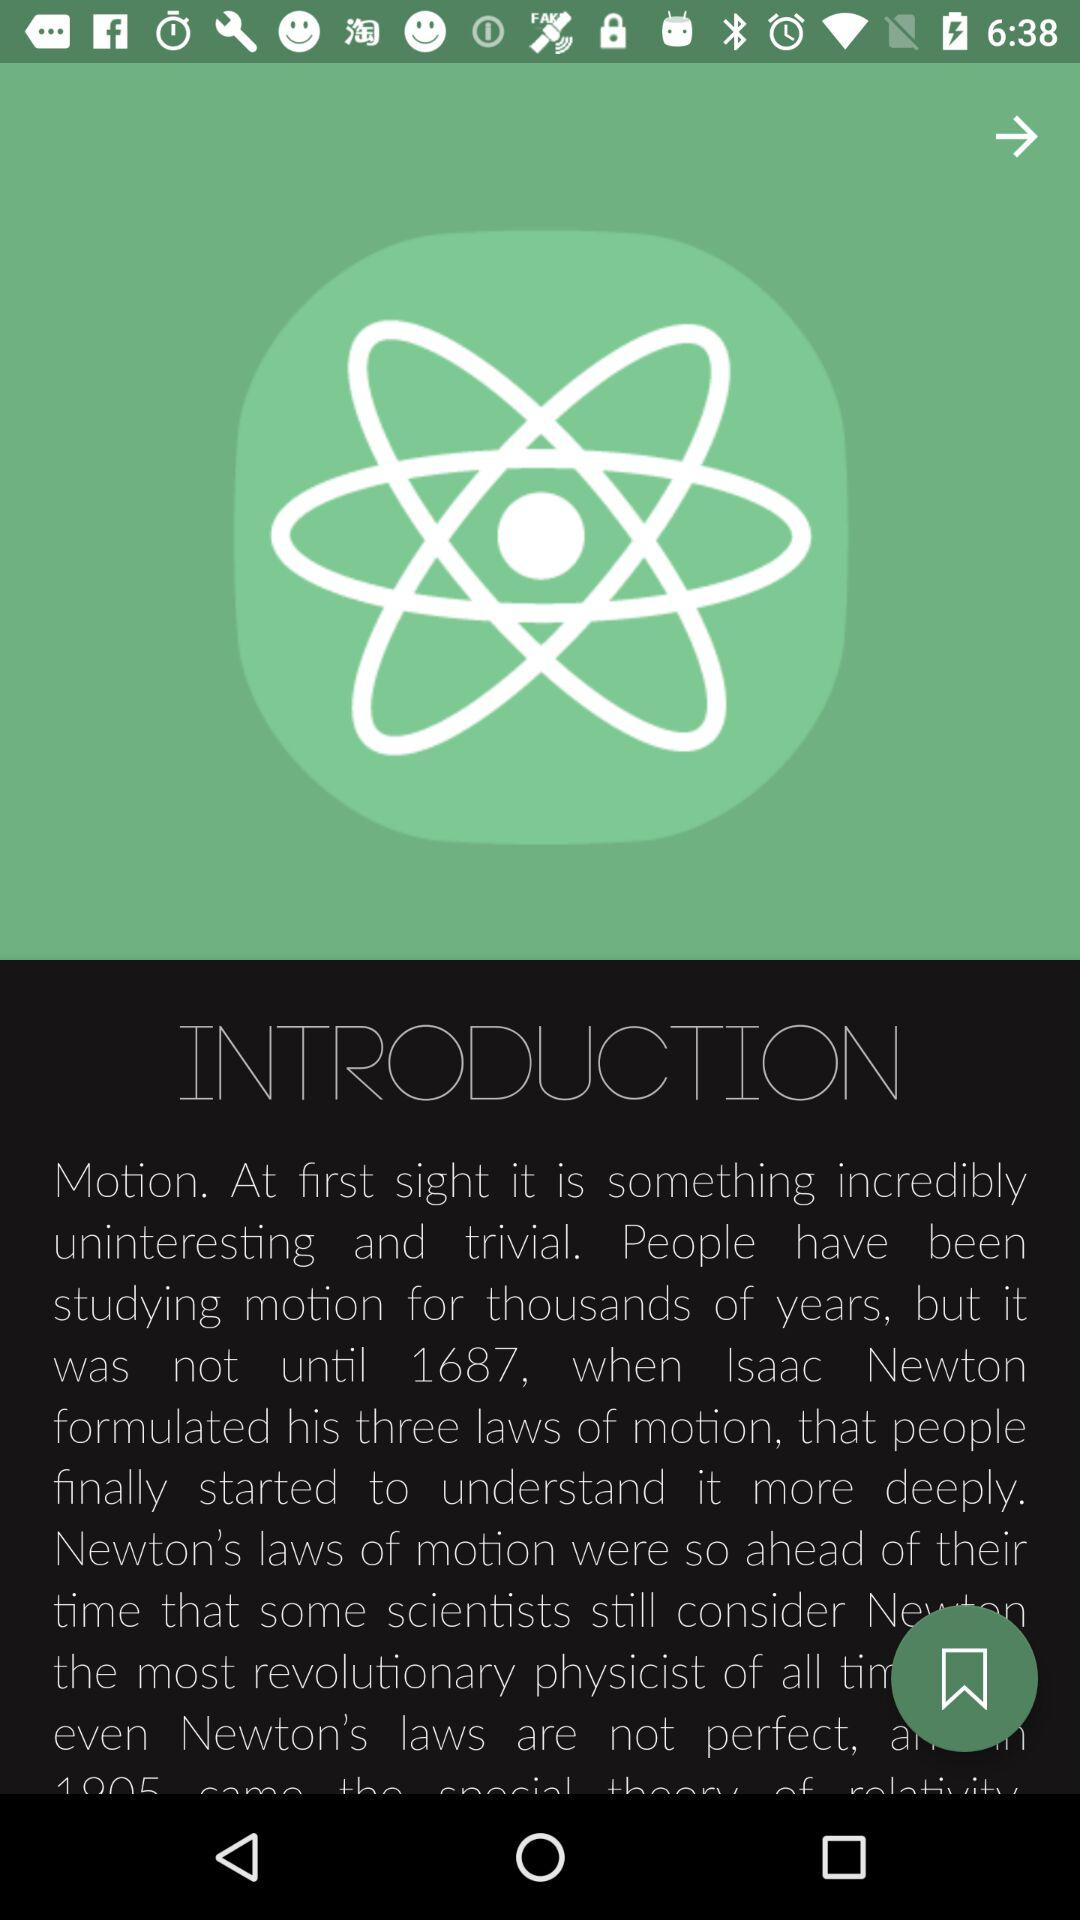In what year did Isaac Newton formulate his three laws of motion? It was formulated in 1687. 